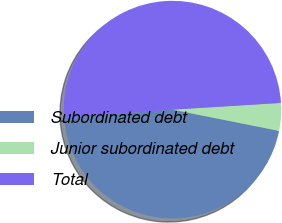Convert chart. <chart><loc_0><loc_0><loc_500><loc_500><pie_chart><fcel>Subordinated debt<fcel>Junior subordinated debt<fcel>Total<nl><fcel>45.66%<fcel>4.12%<fcel>50.22%<nl></chart> 